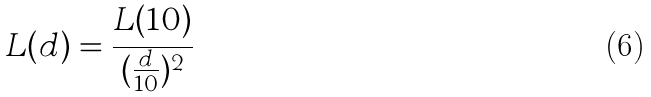Convert formula to latex. <formula><loc_0><loc_0><loc_500><loc_500>L ( d ) = \frac { L ( 1 0 ) } { ( \frac { d } { 1 0 } ) ^ { 2 } }</formula> 